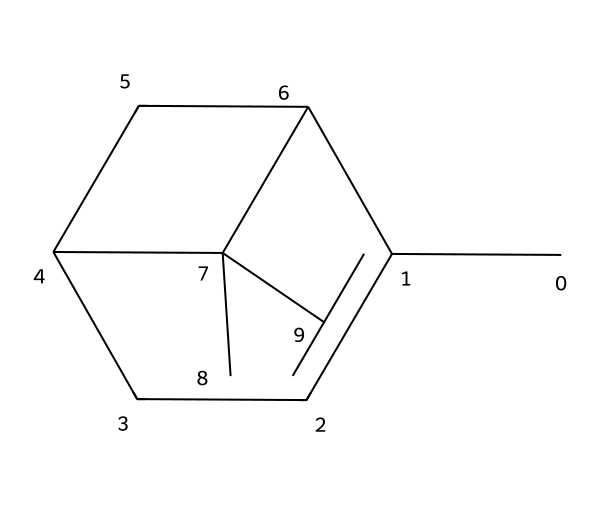How many carbon atoms are in pinene? The SMILES representation indicates that the structure contains 10 carbon atoms, as each 'C' corresponds to a carbon atom.
Answer: 10 What is the molecular formula for pinene? By analyzing the 10 carbon atoms and also considering the hydrogen atoms attached, the molecular formula for pinene can be derived as C10H16.
Answer: C10H16 Is pinene a cyclic compound? The structure includes multiple carbon rings, which confirms that pinene is indeed a cyclic compound.
Answer: Yes What is the degree of unsaturation in pinene? The number of rings and double bonds in the structure leads to a total degree of unsaturation of 3, indicating the presence of one or more cyclic structures and/or double bonds.
Answer: 3 Which terpenoid class does pinene belong to? Given the structure and properties of pinene, it is classified as a monoterpene since it consists of two isoprene units (C5H8) combined.
Answer: Monoterpene Does pinene exhibit optical activity? The presence of a chiral center in the chemical structure indicates that pinene is capable of exhibiting optical activity.
Answer: Yes 